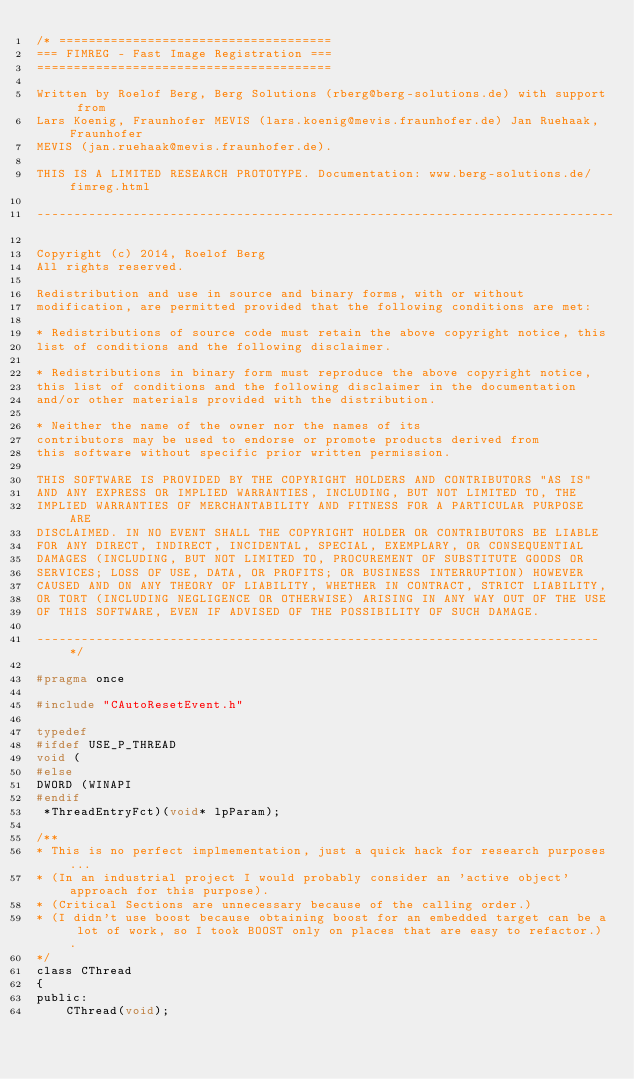<code> <loc_0><loc_0><loc_500><loc_500><_C_>/* =====================================
=== FIMREG - Fast Image Registration ===
========================================

Written by Roelof Berg, Berg Solutions (rberg@berg-solutions.de) with support from
Lars Koenig, Fraunhofer MEVIS (lars.koenig@mevis.fraunhofer.de) Jan Ruehaak, Fraunhofer
MEVIS (jan.ruehaak@mevis.fraunhofer.de).

THIS IS A LIMITED RESEARCH PROTOTYPE. Documentation: www.berg-solutions.de/fimreg.html

------------------------------------------------------------------------------

Copyright (c) 2014, Roelof Berg
All rights reserved.

Redistribution and use in source and binary forms, with or without
modification, are permitted provided that the following conditions are met:

* Redistributions of source code must retain the above copyright notice, this
list of conditions and the following disclaimer.

* Redistributions in binary form must reproduce the above copyright notice,
this list of conditions and the following disclaimer in the documentation
and/or other materials provided with the distribution.

* Neither the name of the owner nor the names of its
contributors may be used to endorse or promote products derived from
this software without specific prior written permission.

THIS SOFTWARE IS PROVIDED BY THE COPYRIGHT HOLDERS AND CONTRIBUTORS "AS IS"
AND ANY EXPRESS OR IMPLIED WARRANTIES, INCLUDING, BUT NOT LIMITED TO, THE
IMPLIED WARRANTIES OF MERCHANTABILITY AND FITNESS FOR A PARTICULAR PURPOSE ARE
DISCLAIMED. IN NO EVENT SHALL THE COPYRIGHT HOLDER OR CONTRIBUTORS BE LIABLE
FOR ANY DIRECT, INDIRECT, INCIDENTAL, SPECIAL, EXEMPLARY, OR CONSEQUENTIAL
DAMAGES (INCLUDING, BUT NOT LIMITED TO, PROCUREMENT OF SUBSTITUTE GOODS OR
SERVICES; LOSS OF USE, DATA, OR PROFITS; OR BUSINESS INTERRUPTION) HOWEVER
CAUSED AND ON ANY THEORY OF LIABILITY, WHETHER IN CONTRACT, STRICT LIABILITY,
OR TORT (INCLUDING NEGLIGENCE OR OTHERWISE) ARISING IN ANY WAY OUT OF THE USE
OF THIS SOFTWARE, EVEN IF ADVISED OF THE POSSIBILITY OF SUCH DAMAGE.

----------------------------------------------------------------------------*/

#pragma once

#include "CAutoResetEvent.h"

typedef
#ifdef USE_P_THREAD
void ( 
#else
DWORD (WINAPI 
#endif
 *ThreadEntryFct)(void* lpParam);

/**
* This is no perfect implmementation, just a quick hack for research purposes...
* (In an industrial project I would probably consider an 'active object' approach for this purpose).
* (Critical Sections are unnecessary because of the calling order.)
* (I didn't use boost because obtaining boost for an embedded target can be a lot of work, so I took BOOST only on places that are easy to refactor.).
*/
class CThread
{
public:
	CThread(void);</code> 